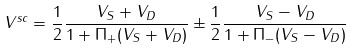<formula> <loc_0><loc_0><loc_500><loc_500>V ^ { s c } = \frac { 1 } { 2 } \frac { V _ { S } + V _ { D } } { 1 + \Pi _ { + } ( V _ { S } + V _ { D } ) } \pm \frac { 1 } { 2 } \frac { V _ { S } - V _ { D } } { 1 + \Pi _ { - } ( V _ { S } - V _ { D } ) }</formula> 